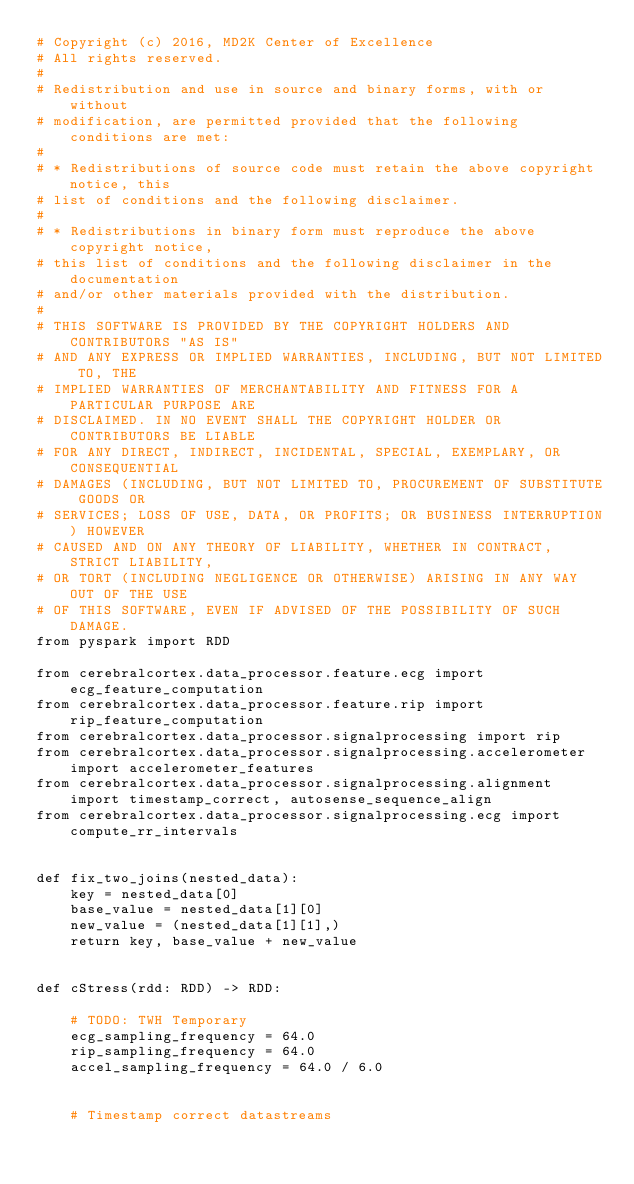<code> <loc_0><loc_0><loc_500><loc_500><_Python_># Copyright (c) 2016, MD2K Center of Excellence
# All rights reserved.
#
# Redistribution and use in source and binary forms, with or without
# modification, are permitted provided that the following conditions are met:
#
# * Redistributions of source code must retain the above copyright notice, this
# list of conditions and the following disclaimer.
#
# * Redistributions in binary form must reproduce the above copyright notice,
# this list of conditions and the following disclaimer in the documentation
# and/or other materials provided with the distribution.
#
# THIS SOFTWARE IS PROVIDED BY THE COPYRIGHT HOLDERS AND CONTRIBUTORS "AS IS"
# AND ANY EXPRESS OR IMPLIED WARRANTIES, INCLUDING, BUT NOT LIMITED TO, THE
# IMPLIED WARRANTIES OF MERCHANTABILITY AND FITNESS FOR A PARTICULAR PURPOSE ARE
# DISCLAIMED. IN NO EVENT SHALL THE COPYRIGHT HOLDER OR CONTRIBUTORS BE LIABLE
# FOR ANY DIRECT, INDIRECT, INCIDENTAL, SPECIAL, EXEMPLARY, OR CONSEQUENTIAL
# DAMAGES (INCLUDING, BUT NOT LIMITED TO, PROCUREMENT OF SUBSTITUTE GOODS OR
# SERVICES; LOSS OF USE, DATA, OR PROFITS; OR BUSINESS INTERRUPTION) HOWEVER
# CAUSED AND ON ANY THEORY OF LIABILITY, WHETHER IN CONTRACT, STRICT LIABILITY,
# OR TORT (INCLUDING NEGLIGENCE OR OTHERWISE) ARISING IN ANY WAY OUT OF THE USE
# OF THIS SOFTWARE, EVEN IF ADVISED OF THE POSSIBILITY OF SUCH DAMAGE.
from pyspark import RDD

from cerebralcortex.data_processor.feature.ecg import ecg_feature_computation
from cerebralcortex.data_processor.feature.rip import rip_feature_computation
from cerebralcortex.data_processor.signalprocessing import rip
from cerebralcortex.data_processor.signalprocessing.accelerometer import accelerometer_features
from cerebralcortex.data_processor.signalprocessing.alignment import timestamp_correct, autosense_sequence_align
from cerebralcortex.data_processor.signalprocessing.ecg import compute_rr_intervals


def fix_two_joins(nested_data):
    key = nested_data[0]
    base_value = nested_data[1][0]
    new_value = (nested_data[1][1],)
    return key, base_value + new_value


def cStress(rdd: RDD) -> RDD:

    # TODO: TWH Temporary
    ecg_sampling_frequency = 64.0
    rip_sampling_frequency = 64.0
    accel_sampling_frequency = 64.0 / 6.0


    # Timestamp correct datastreams</code> 